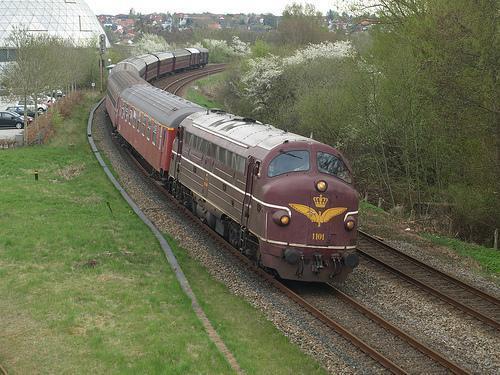How many train cars are there?
Give a very brief answer. 9. 